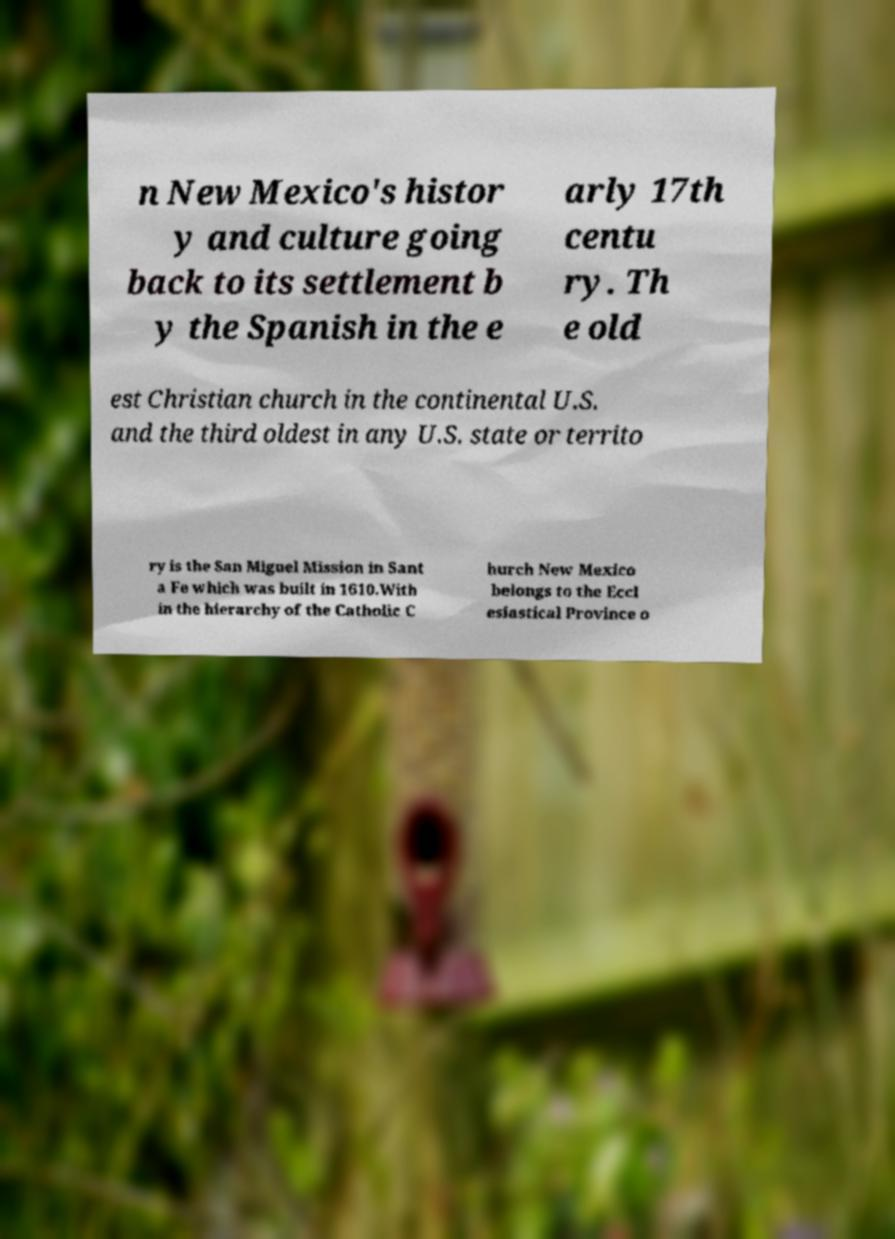Please identify and transcribe the text found in this image. n New Mexico's histor y and culture going back to its settlement b y the Spanish in the e arly 17th centu ry. Th e old est Christian church in the continental U.S. and the third oldest in any U.S. state or territo ry is the San Miguel Mission in Sant a Fe which was built in 1610.With in the hierarchy of the Catholic C hurch New Mexico belongs to the Eccl esiastical Province o 